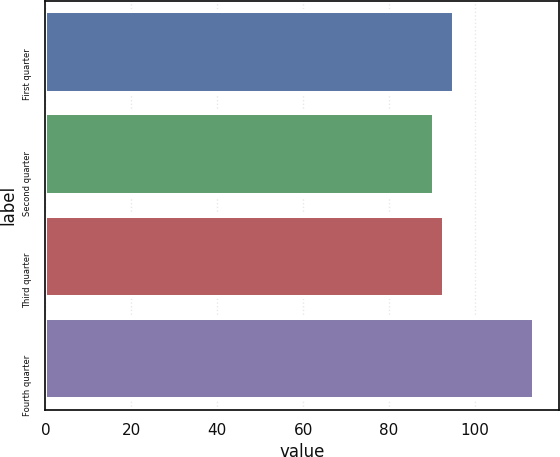<chart> <loc_0><loc_0><loc_500><loc_500><bar_chart><fcel>First quarter<fcel>Second quarter<fcel>Third quarter<fcel>Fourth quarter<nl><fcel>95.11<fcel>90.43<fcel>92.77<fcel>113.84<nl></chart> 